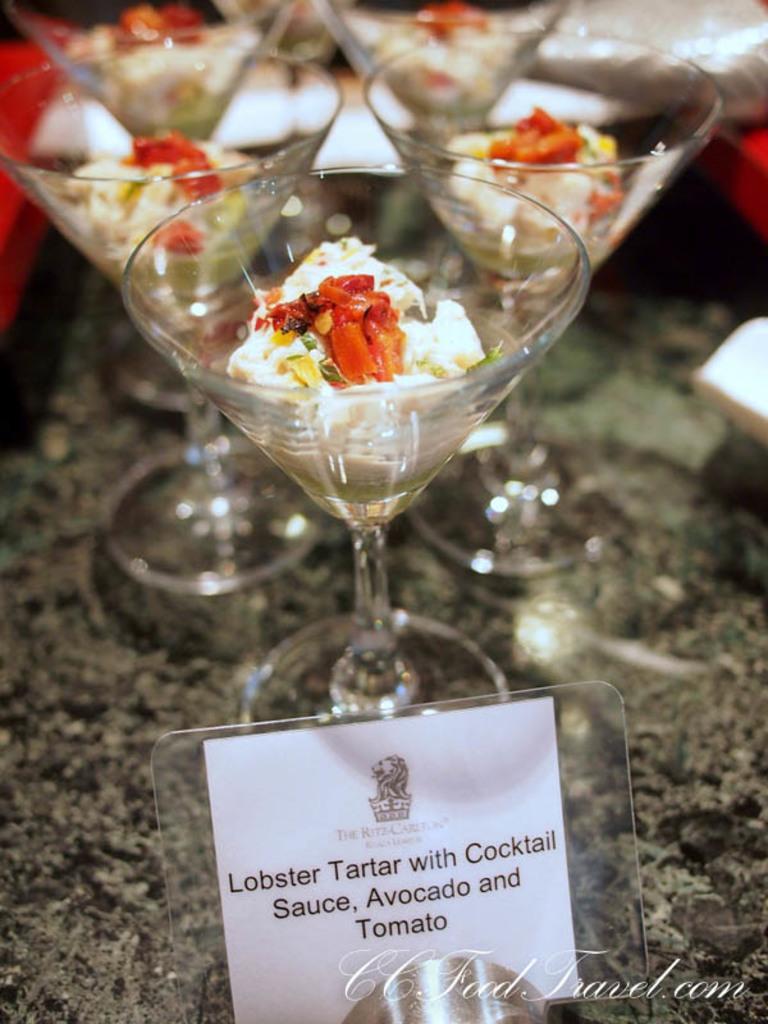Describe this image in one or two sentences. In this picture, there are group of glasses with some food. At the bottom, there is a paper with some text. 